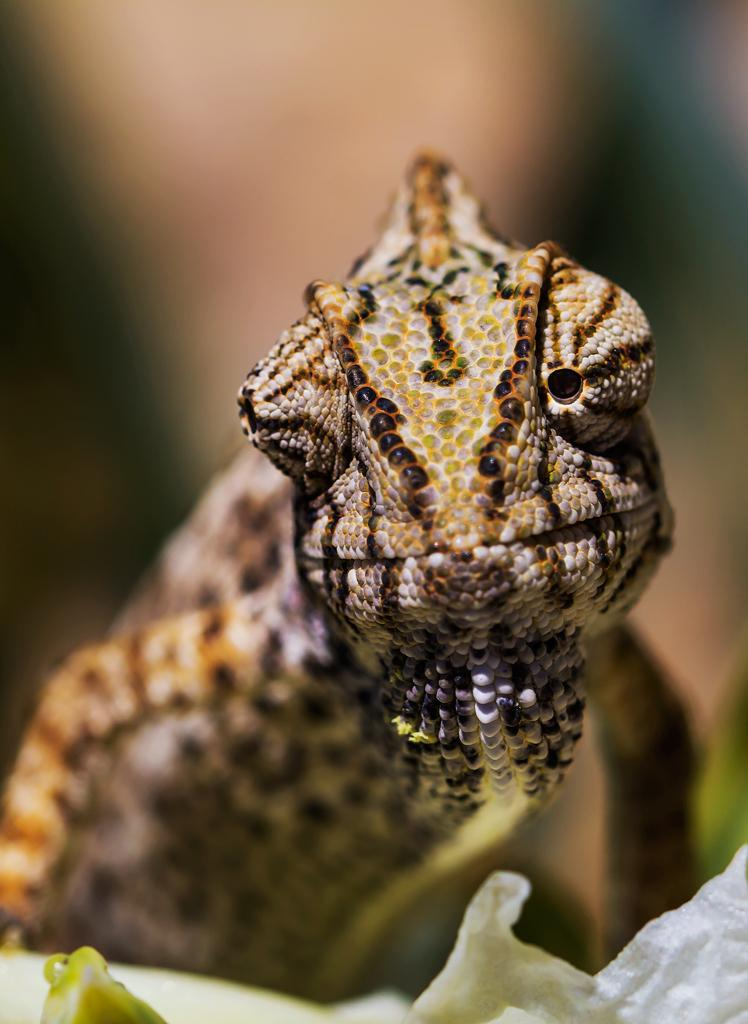What can be observed about the animal in the image? The animal in the image has one eye opened. What color object is on the right side of the image? There is a white color object on the right side of the image. How would you describe the background of the image? The background of the image is blurred. What type of dress is the animal wearing in the image? There is no dress present in the image, as it features an animal with one eye opened and a white color object on the right side of the image. 